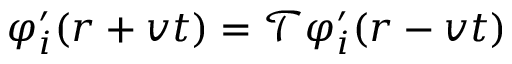Convert formula to latex. <formula><loc_0><loc_0><loc_500><loc_500>\varphi _ { i } ^ { \prime } ( r + v t ) = \mathcal { T } \varphi _ { i } ^ { \prime } ( r - v t )</formula> 